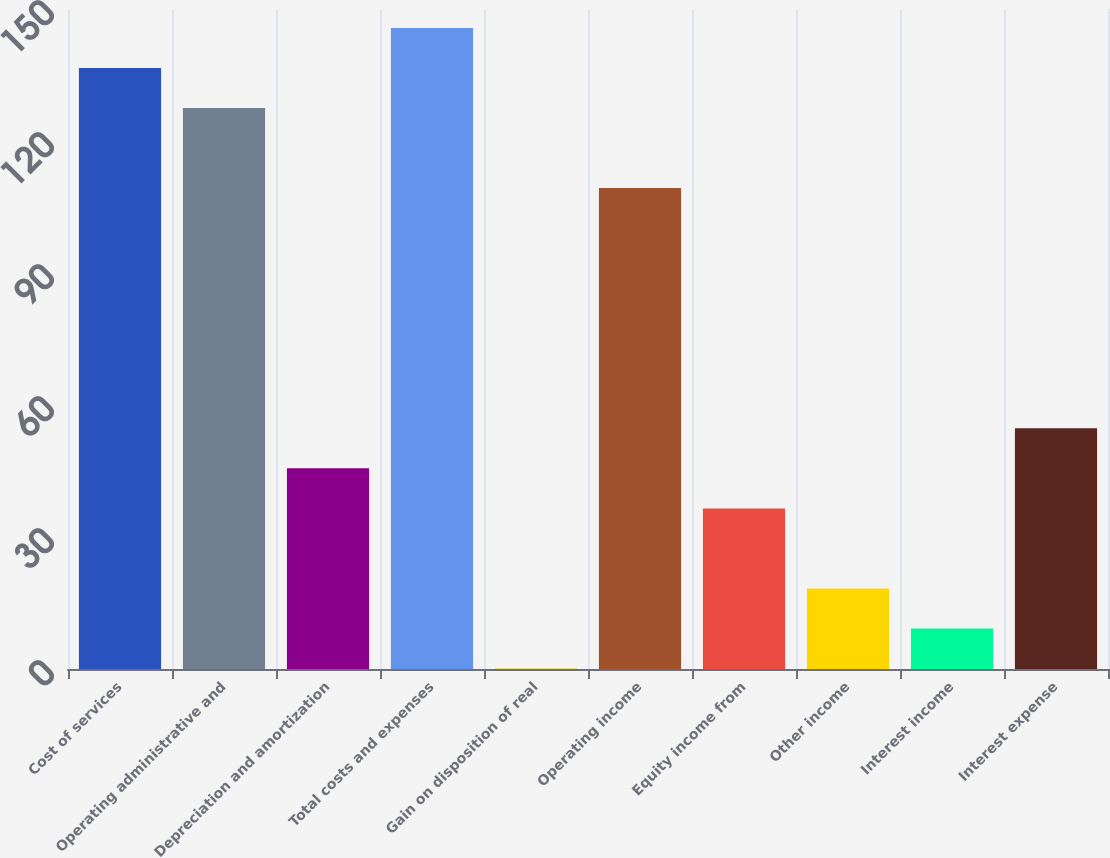<chart> <loc_0><loc_0><loc_500><loc_500><bar_chart><fcel>Cost of services<fcel>Operating administrative and<fcel>Depreciation and amortization<fcel>Total costs and expenses<fcel>Gain on disposition of real<fcel>Operating income<fcel>Equity income from<fcel>Other income<fcel>Interest income<fcel>Interest expense<nl><fcel>136.6<fcel>127.5<fcel>45.6<fcel>145.7<fcel>0.1<fcel>109.3<fcel>36.5<fcel>18.3<fcel>9.2<fcel>54.7<nl></chart> 